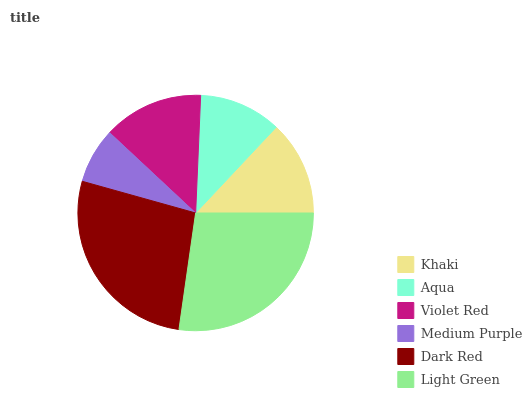Is Medium Purple the minimum?
Answer yes or no. Yes. Is Light Green the maximum?
Answer yes or no. Yes. Is Aqua the minimum?
Answer yes or no. No. Is Aqua the maximum?
Answer yes or no. No. Is Khaki greater than Aqua?
Answer yes or no. Yes. Is Aqua less than Khaki?
Answer yes or no. Yes. Is Aqua greater than Khaki?
Answer yes or no. No. Is Khaki less than Aqua?
Answer yes or no. No. Is Violet Red the high median?
Answer yes or no. Yes. Is Khaki the low median?
Answer yes or no. Yes. Is Light Green the high median?
Answer yes or no. No. Is Aqua the low median?
Answer yes or no. No. 